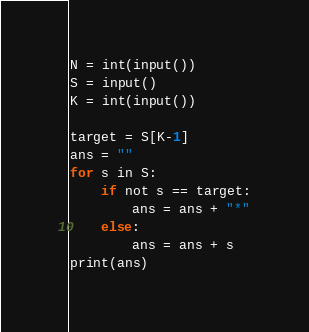<code> <loc_0><loc_0><loc_500><loc_500><_Python_>
N = int(input())
S = input()
K = int(input())

target = S[K-1]
ans = ""
for s in S:
    if not s == target:
        ans = ans + "*"
    else:
        ans = ans + s
print(ans)</code> 